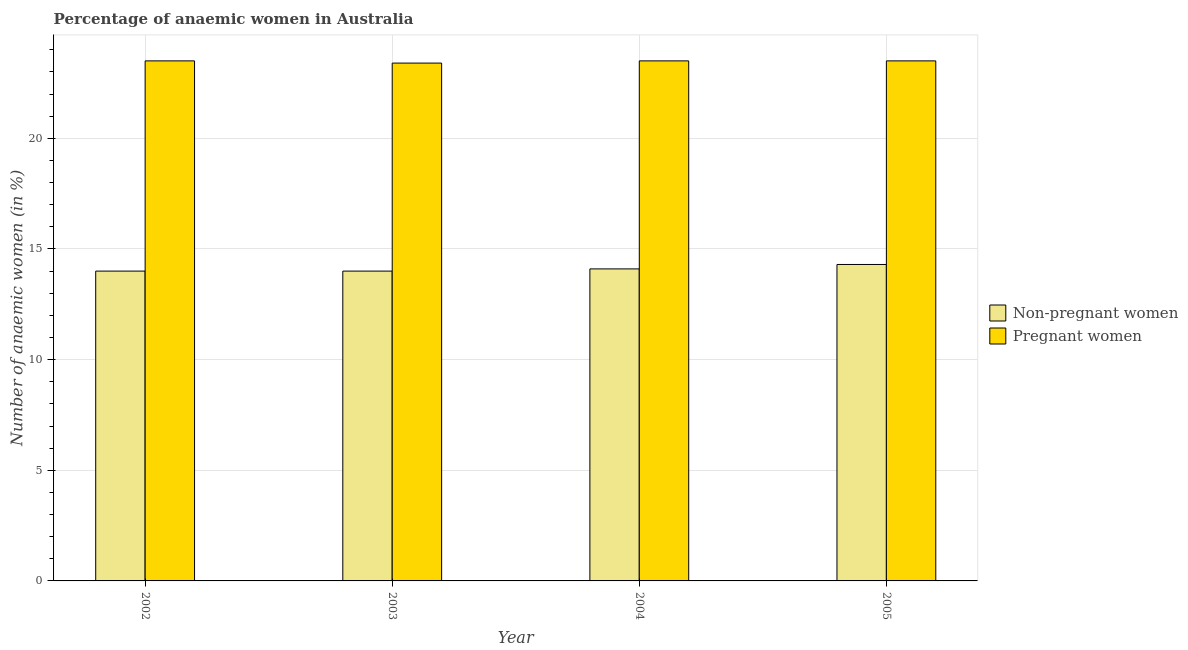Are the number of bars per tick equal to the number of legend labels?
Provide a succinct answer. Yes. How many bars are there on the 3rd tick from the right?
Give a very brief answer. 2. What is the label of the 2nd group of bars from the left?
Offer a terse response. 2003. In how many cases, is the number of bars for a given year not equal to the number of legend labels?
Ensure brevity in your answer.  0. Across all years, what is the minimum percentage of pregnant anaemic women?
Your response must be concise. 23.4. What is the total percentage of pregnant anaemic women in the graph?
Offer a terse response. 93.9. What is the difference between the percentage of pregnant anaemic women in 2002 and that in 2004?
Provide a succinct answer. 0. What is the difference between the percentage of pregnant anaemic women in 2003 and the percentage of non-pregnant anaemic women in 2002?
Ensure brevity in your answer.  -0.1. What is the average percentage of non-pregnant anaemic women per year?
Offer a terse response. 14.1. What is the ratio of the percentage of non-pregnant anaemic women in 2003 to that in 2004?
Make the answer very short. 0.99. Is the percentage of pregnant anaemic women in 2002 less than that in 2003?
Make the answer very short. No. Is the difference between the percentage of non-pregnant anaemic women in 2002 and 2005 greater than the difference between the percentage of pregnant anaemic women in 2002 and 2005?
Ensure brevity in your answer.  No. What is the difference between the highest and the second highest percentage of non-pregnant anaemic women?
Make the answer very short. 0.2. What is the difference between the highest and the lowest percentage of non-pregnant anaemic women?
Provide a succinct answer. 0.3. Is the sum of the percentage of non-pregnant anaemic women in 2002 and 2005 greater than the maximum percentage of pregnant anaemic women across all years?
Offer a very short reply. Yes. What does the 1st bar from the left in 2005 represents?
Offer a terse response. Non-pregnant women. What does the 1st bar from the right in 2004 represents?
Make the answer very short. Pregnant women. How many bars are there?
Your answer should be compact. 8. Are all the bars in the graph horizontal?
Provide a succinct answer. No. How many years are there in the graph?
Offer a terse response. 4. Are the values on the major ticks of Y-axis written in scientific E-notation?
Keep it short and to the point. No. Does the graph contain any zero values?
Make the answer very short. No. Does the graph contain grids?
Your answer should be compact. Yes. Where does the legend appear in the graph?
Keep it short and to the point. Center right. How are the legend labels stacked?
Give a very brief answer. Vertical. What is the title of the graph?
Your answer should be compact. Percentage of anaemic women in Australia. Does "Domestic Liabilities" appear as one of the legend labels in the graph?
Ensure brevity in your answer.  No. What is the label or title of the X-axis?
Your response must be concise. Year. What is the label or title of the Y-axis?
Offer a terse response. Number of anaemic women (in %). What is the Number of anaemic women (in %) of Non-pregnant women in 2002?
Provide a succinct answer. 14. What is the Number of anaemic women (in %) in Pregnant women in 2002?
Keep it short and to the point. 23.5. What is the Number of anaemic women (in %) of Non-pregnant women in 2003?
Your answer should be very brief. 14. What is the Number of anaemic women (in %) of Pregnant women in 2003?
Your response must be concise. 23.4. What is the Number of anaemic women (in %) of Non-pregnant women in 2005?
Offer a very short reply. 14.3. What is the Number of anaemic women (in %) in Pregnant women in 2005?
Provide a succinct answer. 23.5. Across all years, what is the maximum Number of anaemic women (in %) in Pregnant women?
Provide a succinct answer. 23.5. Across all years, what is the minimum Number of anaemic women (in %) of Pregnant women?
Make the answer very short. 23.4. What is the total Number of anaemic women (in %) in Non-pregnant women in the graph?
Your answer should be very brief. 56.4. What is the total Number of anaemic women (in %) of Pregnant women in the graph?
Your answer should be compact. 93.9. What is the difference between the Number of anaemic women (in %) in Non-pregnant women in 2002 and that in 2004?
Make the answer very short. -0.1. What is the difference between the Number of anaemic women (in %) in Pregnant women in 2002 and that in 2004?
Keep it short and to the point. 0. What is the difference between the Number of anaemic women (in %) of Non-pregnant women in 2002 and that in 2005?
Ensure brevity in your answer.  -0.3. What is the difference between the Number of anaemic women (in %) in Pregnant women in 2002 and that in 2005?
Offer a very short reply. 0. What is the difference between the Number of anaemic women (in %) in Non-pregnant women in 2003 and that in 2005?
Your answer should be very brief. -0.3. What is the difference between the Number of anaemic women (in %) of Pregnant women in 2003 and that in 2005?
Offer a terse response. -0.1. What is the difference between the Number of anaemic women (in %) in Non-pregnant women in 2004 and that in 2005?
Offer a terse response. -0.2. What is the difference between the Number of anaemic women (in %) of Non-pregnant women in 2002 and the Number of anaemic women (in %) of Pregnant women in 2004?
Provide a short and direct response. -9.5. What is the difference between the Number of anaemic women (in %) in Non-pregnant women in 2002 and the Number of anaemic women (in %) in Pregnant women in 2005?
Ensure brevity in your answer.  -9.5. What is the difference between the Number of anaemic women (in %) in Non-pregnant women in 2003 and the Number of anaemic women (in %) in Pregnant women in 2005?
Provide a succinct answer. -9.5. What is the difference between the Number of anaemic women (in %) of Non-pregnant women in 2004 and the Number of anaemic women (in %) of Pregnant women in 2005?
Provide a succinct answer. -9.4. What is the average Number of anaemic women (in %) in Non-pregnant women per year?
Offer a very short reply. 14.1. What is the average Number of anaemic women (in %) of Pregnant women per year?
Ensure brevity in your answer.  23.48. In the year 2002, what is the difference between the Number of anaemic women (in %) in Non-pregnant women and Number of anaemic women (in %) in Pregnant women?
Your answer should be compact. -9.5. In the year 2004, what is the difference between the Number of anaemic women (in %) of Non-pregnant women and Number of anaemic women (in %) of Pregnant women?
Your answer should be very brief. -9.4. What is the ratio of the Number of anaemic women (in %) of Non-pregnant women in 2002 to that in 2003?
Offer a very short reply. 1. What is the ratio of the Number of anaemic women (in %) of Pregnant women in 2002 to that in 2003?
Offer a terse response. 1. What is the ratio of the Number of anaemic women (in %) in Non-pregnant women in 2002 to that in 2004?
Your answer should be very brief. 0.99. What is the ratio of the Number of anaemic women (in %) in Pregnant women in 2002 to that in 2004?
Provide a short and direct response. 1. What is the ratio of the Number of anaemic women (in %) of Non-pregnant women in 2002 to that in 2005?
Your answer should be very brief. 0.98. What is the ratio of the Number of anaemic women (in %) of Pregnant women in 2003 to that in 2004?
Make the answer very short. 1. What is the ratio of the Number of anaemic women (in %) in Non-pregnant women in 2003 to that in 2005?
Your answer should be very brief. 0.98. What is the ratio of the Number of anaemic women (in %) in Pregnant women in 2003 to that in 2005?
Offer a terse response. 1. What is the difference between the highest and the second highest Number of anaemic women (in %) in Non-pregnant women?
Provide a succinct answer. 0.2. What is the difference between the highest and the second highest Number of anaemic women (in %) of Pregnant women?
Your answer should be very brief. 0. What is the difference between the highest and the lowest Number of anaemic women (in %) of Pregnant women?
Give a very brief answer. 0.1. 